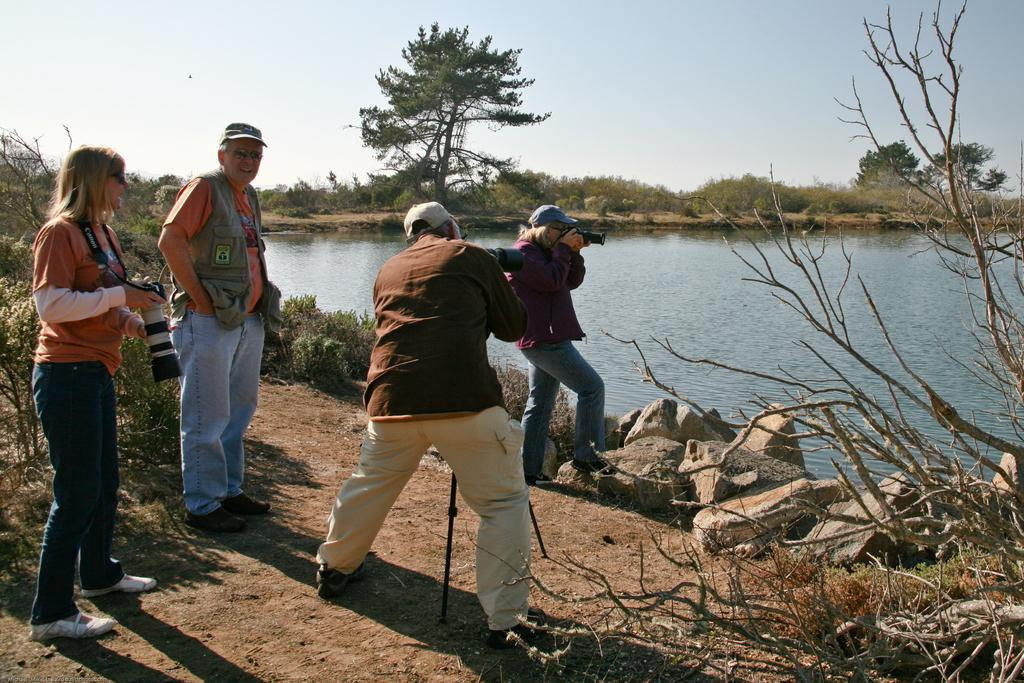How many people are in the image? There are people in the image, but the exact number is not specified. What are some of the people doing in the image? Some of the people are holding cameras in the image. What type of natural elements can be seen in the image? There are trees, stones, water, and plants in the image. What can be seen in the background of the image? The sky is visible in the background of the image. What type of cable can be seen hanging from the trees in the image? There is no cable hanging from the trees in the image; only trees, stones, water, and plants are present. What type of wall can be seen in the image? There is no wall present in the image; the focus is on the people, natural elements, and the sky. 